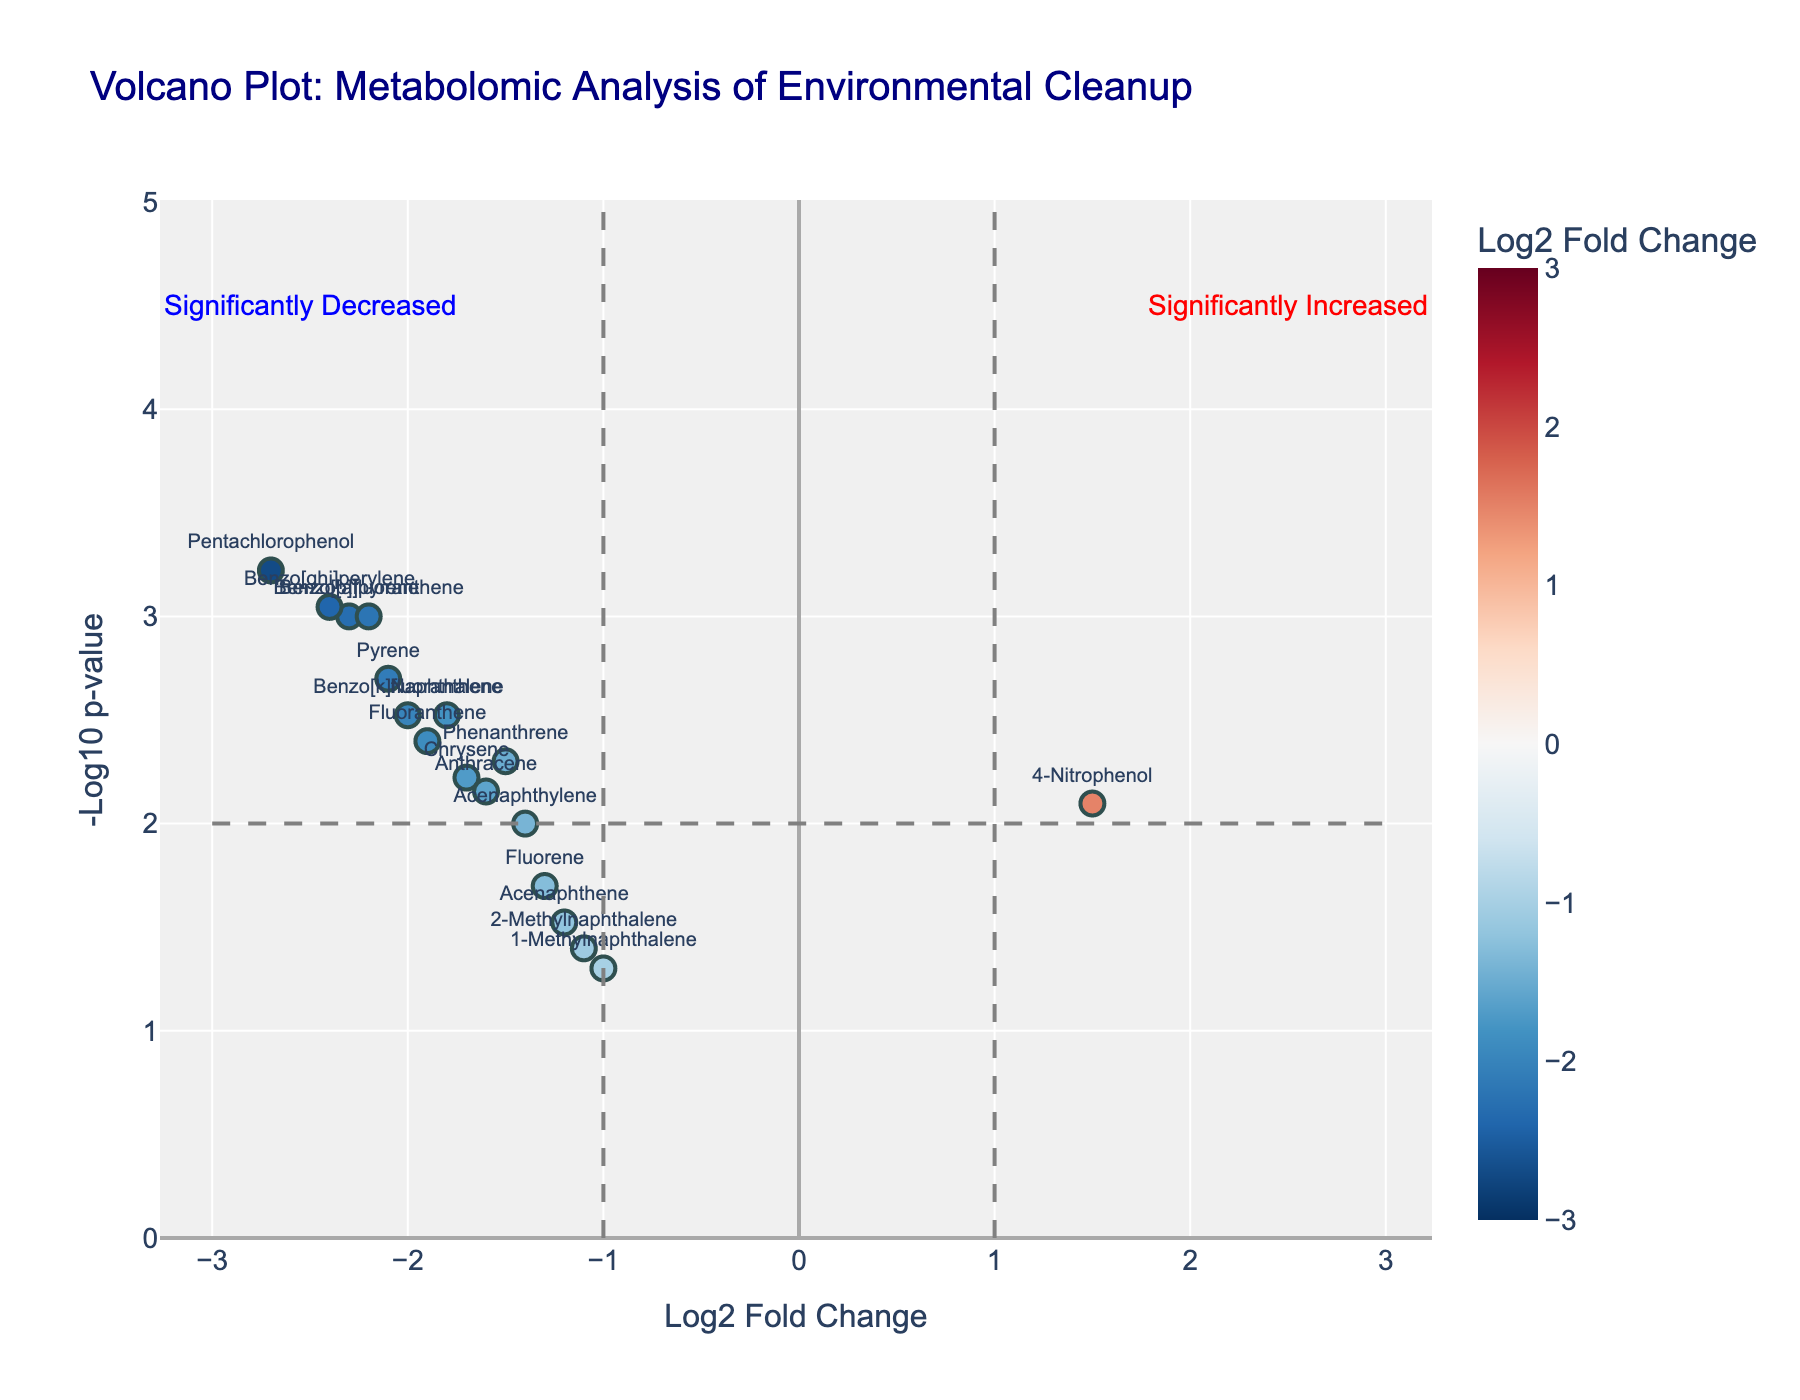How many metabolites are plotted in the figure? Count the total number of metabolite labels on the plot. Each point represents a metabolite, and there are 17 labels on the plot.
Answer: 17 Which metabolite has the highest -log10 p-value? Look for the point that is the highest on the y-axis. Benzo[ghi]perylene has the highest -log10 p-value.
Answer: Benzo[ghi]perylene What is the log2 fold change of Pentachlorophenol? Find the point labeled Pentachlorophenol and look at its position on the x-axis. It is at -2.7.
Answer: -2.7 Which metabolite shows a significant increase in the plot? Significant increases are indicated by points on the right side of the plot with a log2 fold change greater than 1 and a -log10 p-value greater than 2. 4-Nitrophenol is the only metabolite that fits these criteria.
Answer: 4-Nitrophenol How many metabolites have a log2 fold change less than -2? Count the points to the left of the -2 mark on the x-axis. There are 5 points: Benzo[a]pyrene, Pyrene, Benzo[b]fluoranthene, Benzo[ghi]perylene, and Pentachlorophenol.
Answer: 5 Compare Benzo[a]pyrene and Chrysene in terms of their p-values. Which one is more significant? Compare the -log10 p-values of both metabolites. The higher the -log10 p-value, the more significant it is. Benzo[a]pyrene has a higher -log10 p-value than Chrysene, making it more significant.
Answer: Benzo[a]pyrene What is the average log2 fold change of Benzo[a]pyrene, Pyrene, and Fluoranthene? Sum the log2 fold changes of these three metabolites (-2.3, -2.1, -1.9) and divide by 3: (-2.3 - 2.1 - 1.9) / 3 = -2.1.
Answer: -2.1 How many metabolites have a p-value below 0.005? Identify the points with a -log10 p-value greater than log10(0.005) ≈ 2.301. There are 7 metabolites: Benzo[a]pyrene, Pyrene, Benzo[b]fluoranthene, Benzo[ghi]perylene, Pentachlorophenol, Naphthalene, and 4-Nitrophenol.
Answer: 7 